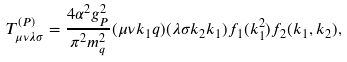Convert formula to latex. <formula><loc_0><loc_0><loc_500><loc_500>T ^ { ( P ) } _ { \mu \nu \lambda \sigma } = \frac { 4 \alpha ^ { 2 } g ^ { 2 } _ { P } } { \pi ^ { 2 } m _ { q } ^ { 2 } } ( \mu \nu k _ { 1 } q ) ( \lambda \sigma k _ { 2 } k _ { 1 } ) f _ { 1 } ( k _ { 1 } ^ { 2 } ) f _ { 2 } ( k _ { 1 } , k _ { 2 } ) ,</formula> 